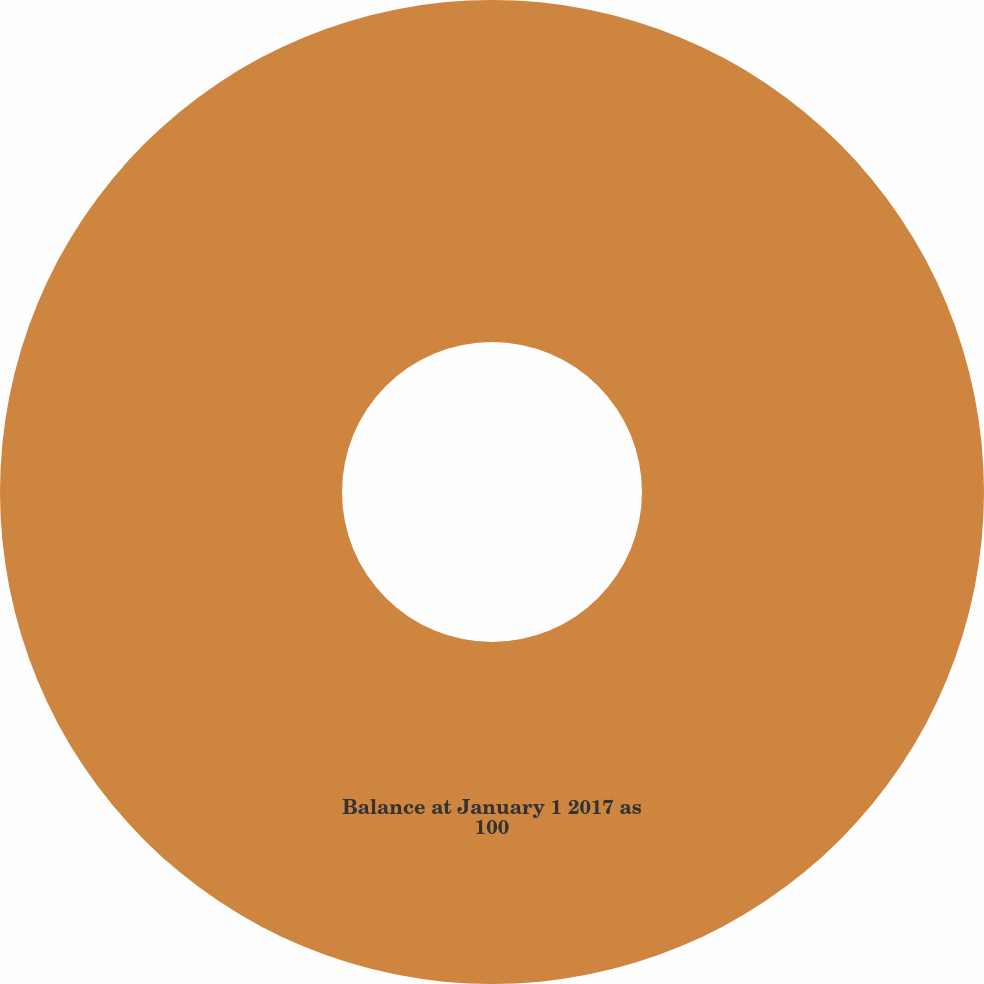Convert chart. <chart><loc_0><loc_0><loc_500><loc_500><pie_chart><fcel>Balance at January 1 2017 as<nl><fcel>100.0%<nl></chart> 